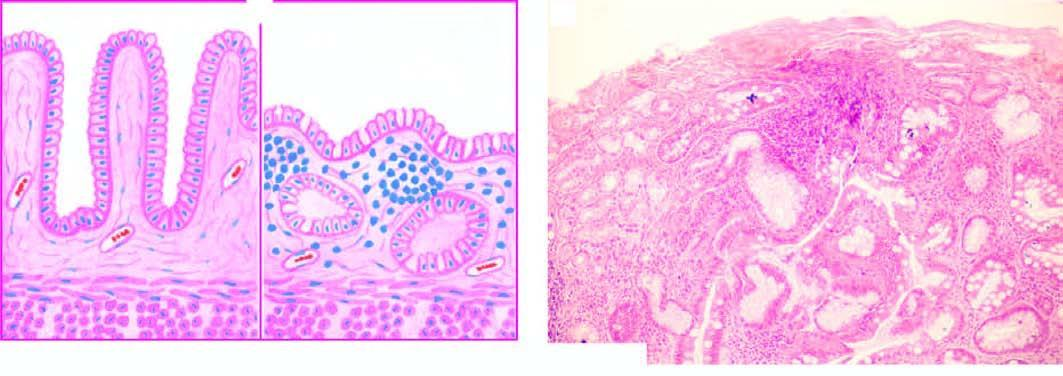what is there of gastric glands and appearance of goblet cells intestinal metaplasia?
Answer the question using a single word or phrase. Marked atrophy with disappearance (intestinal metaplasia) 